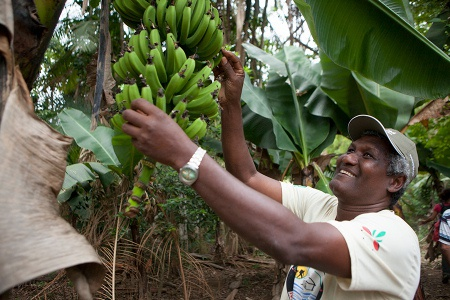Describe the objects in this image and their specific colors. I can see people in gray, lightgray, maroon, black, and brown tones, banana in gray, black, darkgreen, and olive tones, banana in gray, black, and darkgreen tones, clock in gray, darkgray, and tan tones, and backpack in gray, black, and maroon tones in this image. 